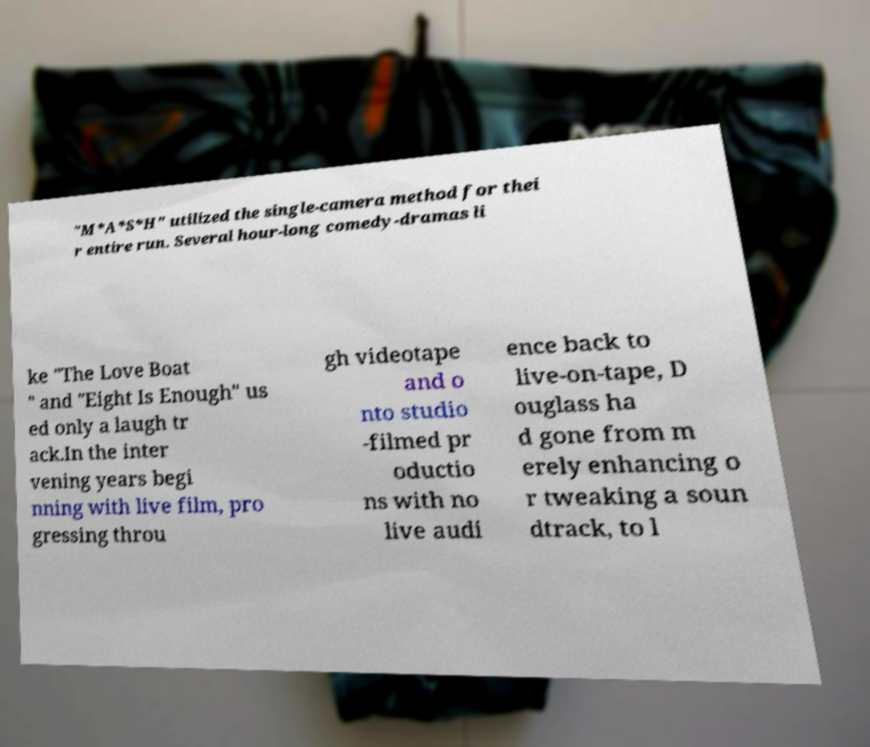Could you extract and type out the text from this image? "M*A*S*H" utilized the single-camera method for thei r entire run. Several hour-long comedy-dramas li ke "The Love Boat " and "Eight Is Enough" us ed only a laugh tr ack.In the inter vening years begi nning with live film, pro gressing throu gh videotape and o nto studio -filmed pr oductio ns with no live audi ence back to live-on-tape, D ouglass ha d gone from m erely enhancing o r tweaking a soun dtrack, to l 